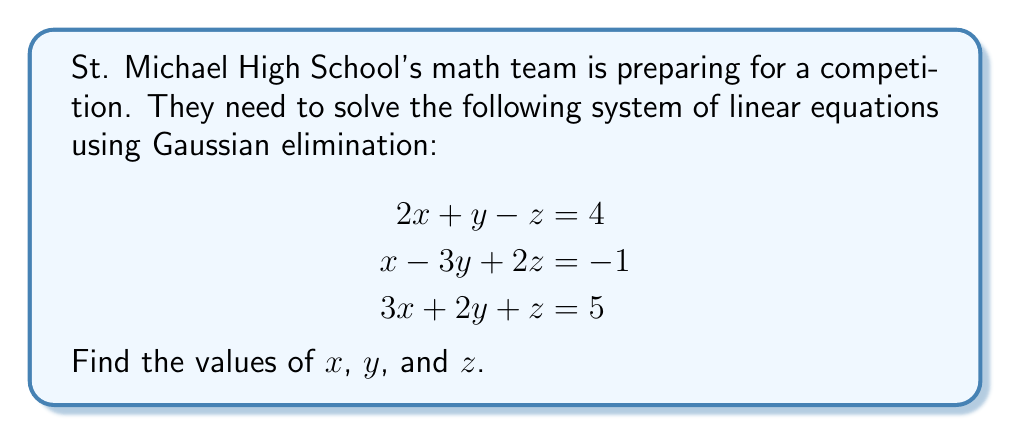What is the answer to this math problem? Let's solve this system using Gaussian elimination:

1) First, write the augmented matrix:

   $$\begin{bmatrix}
   2 & 1 & -1 & | & 4 \\
   1 & -3 & 2 & | & -1 \\
   3 & 2 & 1 & | & 5
   \end{bmatrix}$$

2) Use $R_1$ as the pivot row. Subtract $\frac{1}{2}R_1$ from $R_2$, and $\frac{3}{2}R_1$ from $R_3$:

   $$\begin{bmatrix}
   2 & 1 & -1 & | & 4 \\
   0 & -\frac{7}{2} & \frac{5}{2} & | & -3 \\
   0 & \frac{1}{2} & \frac{5}{2} & | & -1
   \end{bmatrix}$$

3) Now use $R_2$ as the pivot row. Add $\frac{1}{7}R_2$ to $R_3$:

   $$\begin{bmatrix}
   2 & 1 & -1 & | & 4 \\
   0 & -\frac{7}{2} & \frac{5}{2} & | & -3 \\
   0 & 0 & 3 & | & -\frac{4}{7}
   \end{bmatrix}$$

4) The matrix is now in row echelon form. We can solve for $z$ from the last row:

   $3z = -\frac{4}{7}$
   $z = -\frac{4}{21}$

5) Substitute this value in the second row to solve for $y$:

   $-\frac{7}{2}y + \frac{5}{2}(-\frac{4}{21}) = -3$
   $-\frac{7}{2}y - \frac{10}{21} = -3$
   $-\frac{7}{2}y = -\frac{53}{21}$
   $y = \frac{53}{147}$

6) Finally, substitute these values in the first row to solve for $x$:

   $2x + \frac{53}{147} - (-\frac{4}{21}) = 4$
   $2x + \frac{53}{147} + \frac{4}{21} = 4$
   $2x = 4 - \frac{53}{147} - \frac{4}{21}$
   $2x = \frac{588}{147} - \frac{53}{147} - \frac{28}{147} = \frac{507}{147}$
   $x = \frac{507}{294}$

Therefore, the solution is $x = \frac{507}{294}$, $y = \frac{53}{147}$, and $z = -\frac{4}{21}$.
Answer: $x = \frac{507}{294}$, $y = \frac{53}{147}$, $z = -\frac{4}{21}$ 